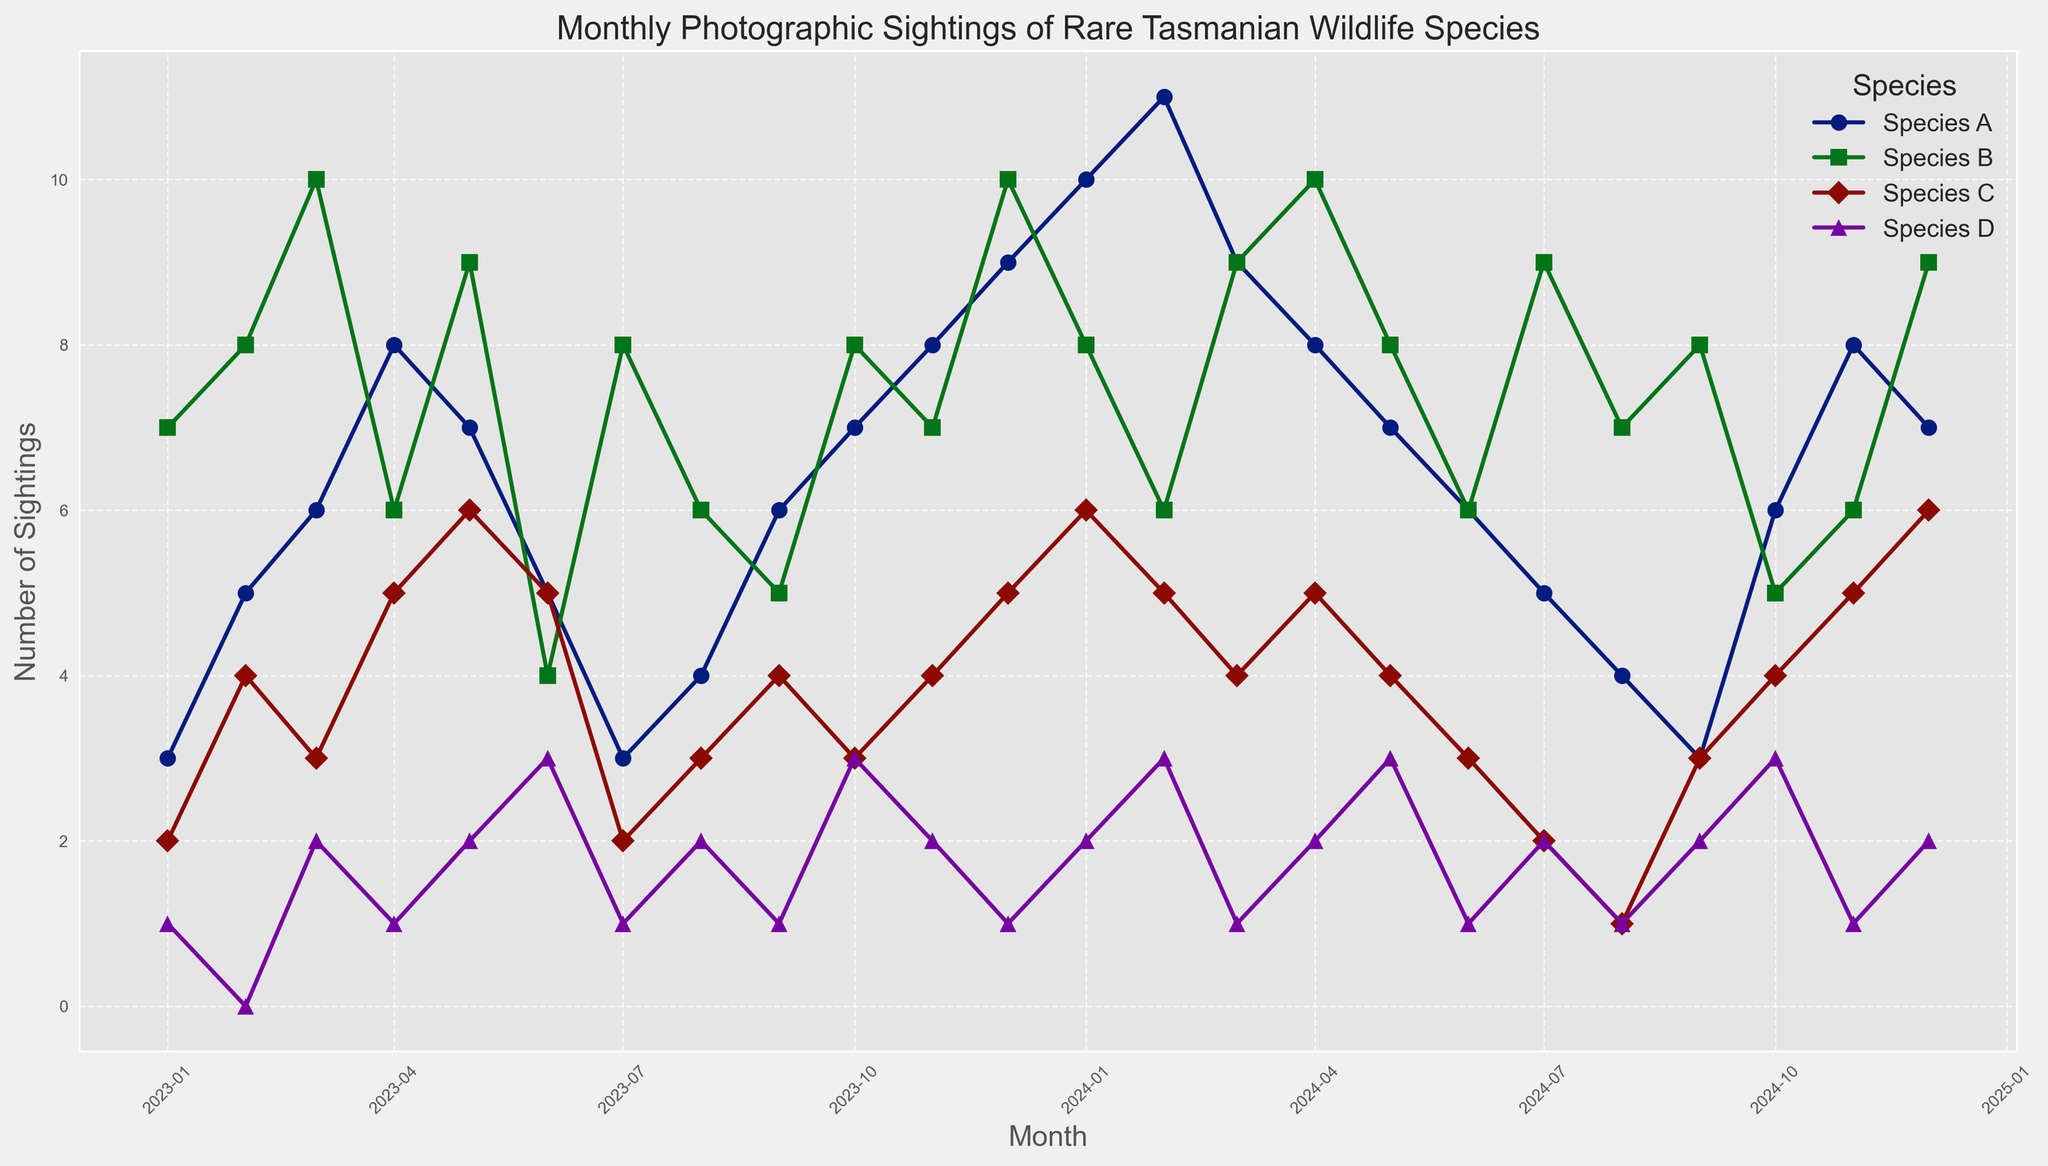When was the highest number of sightings for Species A recorded? The highest point on the line corresponding to Species A should be identified by looking at the peak of that line graph. This peak occurs in February 2024, where sightings reached 11.
Answer: February 2024 Which month had the lowest sightings for Species D? The lowest point on the line corresponding to Species D should be identified by looking at the base of that line graph. This base occurs in February 2023, where sightings were 0.
Answer: February 2023 Which species had the most sightings in December 2024? To answer this question, compare the heights of the lines at December 2024 for each species. Species C had the highest number of sightings in December 2024 with 6 sightings.
Answer: Species C How did the sightings of Species B change from May 2023 to June 2023? Look at the line for Species B between May and June 2023 and observe the change. There was a decrease in sightings from 9 to 4.
Answer: Decreased What is the average number of monthly sightings for Species C in 2023? Add up all the monthly sightings for Species C in the year 2023 and then divide by 12. The sum is 2+4+3+5+6+5+2+3+4+3+4+5 = 46. The average is 46/12 ≈ 3.83.
Answer: 3.83 Between which two months did Species D have the biggest increase in sightings? Look for the steepest upward slope on the line graph for Species D. The largest increase occurred between January 2024 (2 sightings) and February 2024 (3 sightings).
Answer: January 2024 and February 2024 How many months had sightings of Species A greater than or equal to 8? Count the months where the line for Species A is at or above the 8 sightings mark. These months are April 2023, November 2023, December 2023, January 2024, February 2024, March 2024, October 2024, and November 2024 (total of 8 months).
Answer: 8 months Compare the peak sightings of Species A and Species B. Which one was higher and by how much? Identify the highest points on the lines for Species A and Species B and compare them. Species A's peak is 11 sightings in February 2024, and Species B's peak is 10 sightings in December 2023 and April 2024. The difference is 11 - 10 = 1.
Answer: Species A by 1 What is the combined number of sightings for all species in June 2024? Sum the sightings for all species in June 2024. Species A = 6, Species B = 6, Species C = 3, Species D = 1. The total is 6 + 6 + 3 + 1 = 16.
Answer: 16 Was there any month in which all species had the same number of sightings? Scan through each vertical line (monthly) in the figure to see if any month shows all species’ lines meeting at the same point. There are no months where all species had the same sighting number simultaneously.
Answer: No 